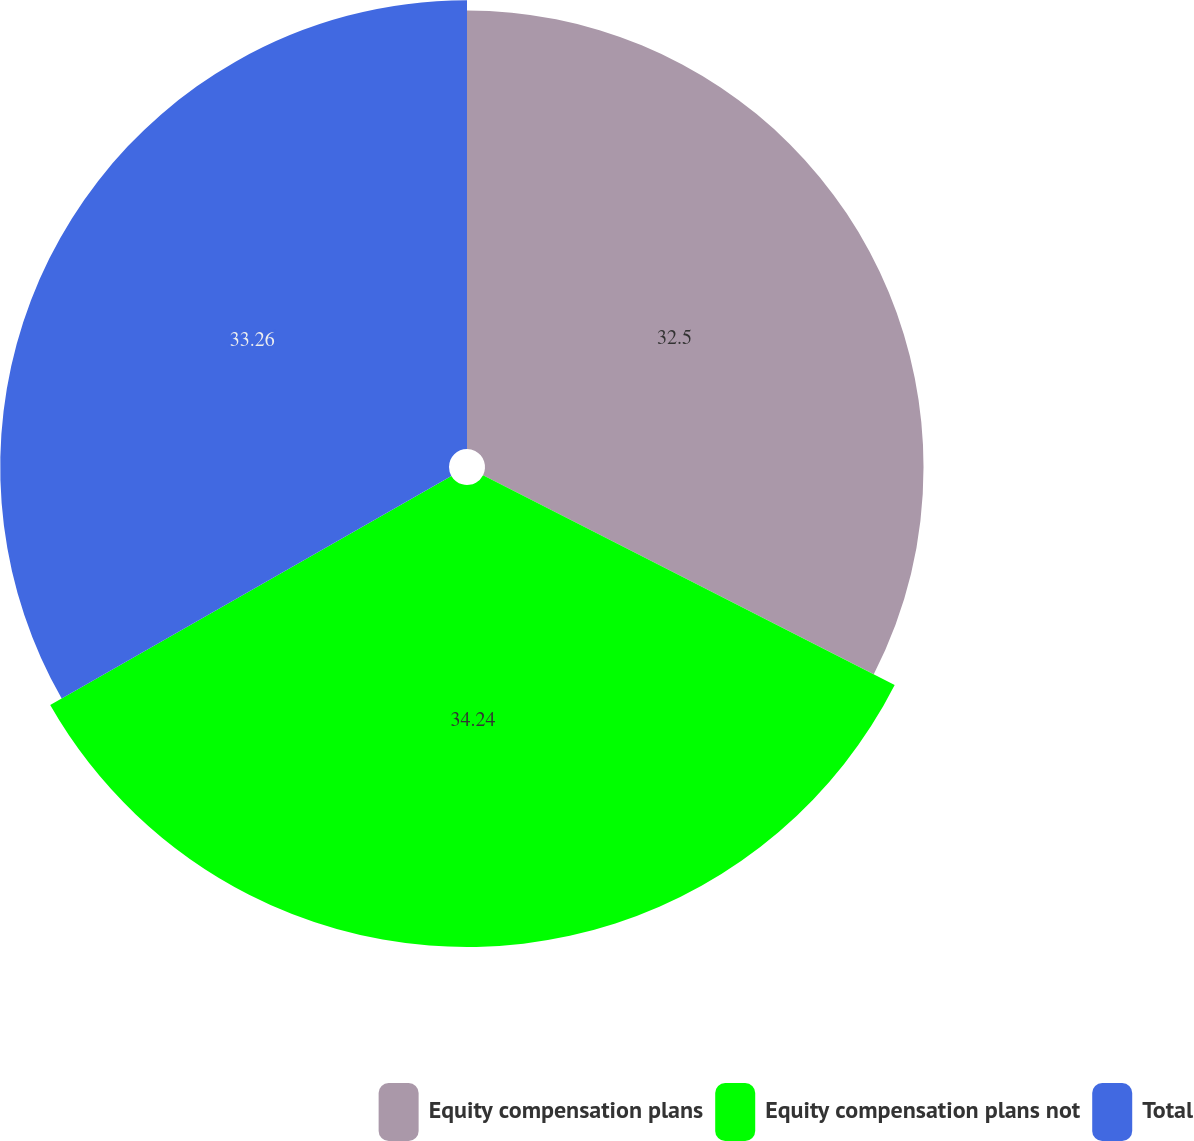<chart> <loc_0><loc_0><loc_500><loc_500><pie_chart><fcel>Equity compensation plans<fcel>Equity compensation plans not<fcel>Total<nl><fcel>32.5%<fcel>34.24%<fcel>33.26%<nl></chart> 